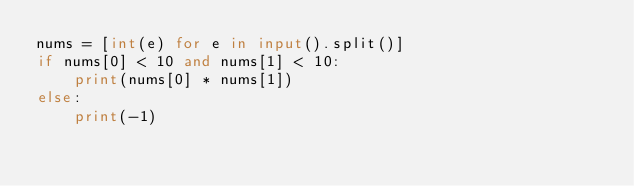Convert code to text. <code><loc_0><loc_0><loc_500><loc_500><_Python_>nums = [int(e) for e in input().split()]
if nums[0] < 10 and nums[1] < 10:
    print(nums[0] * nums[1])
else:
    print(-1)</code> 